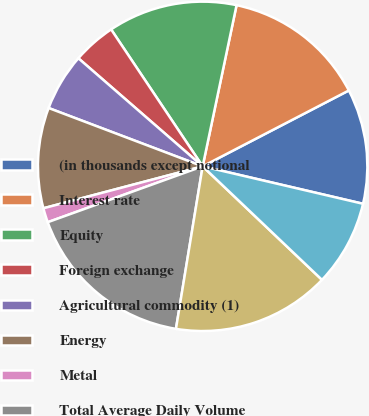<chart> <loc_0><loc_0><loc_500><loc_500><pie_chart><fcel>(in thousands except notional<fcel>Interest rate<fcel>Equity<fcel>Foreign exchange<fcel>Agricultural commodity (1)<fcel>Energy<fcel>Metal<fcel>Total Average Daily Volume<fcel>Electronic<fcel>Open outcry<nl><fcel>11.27%<fcel>14.08%<fcel>12.68%<fcel>4.23%<fcel>5.63%<fcel>9.86%<fcel>1.41%<fcel>16.9%<fcel>15.49%<fcel>8.45%<nl></chart> 